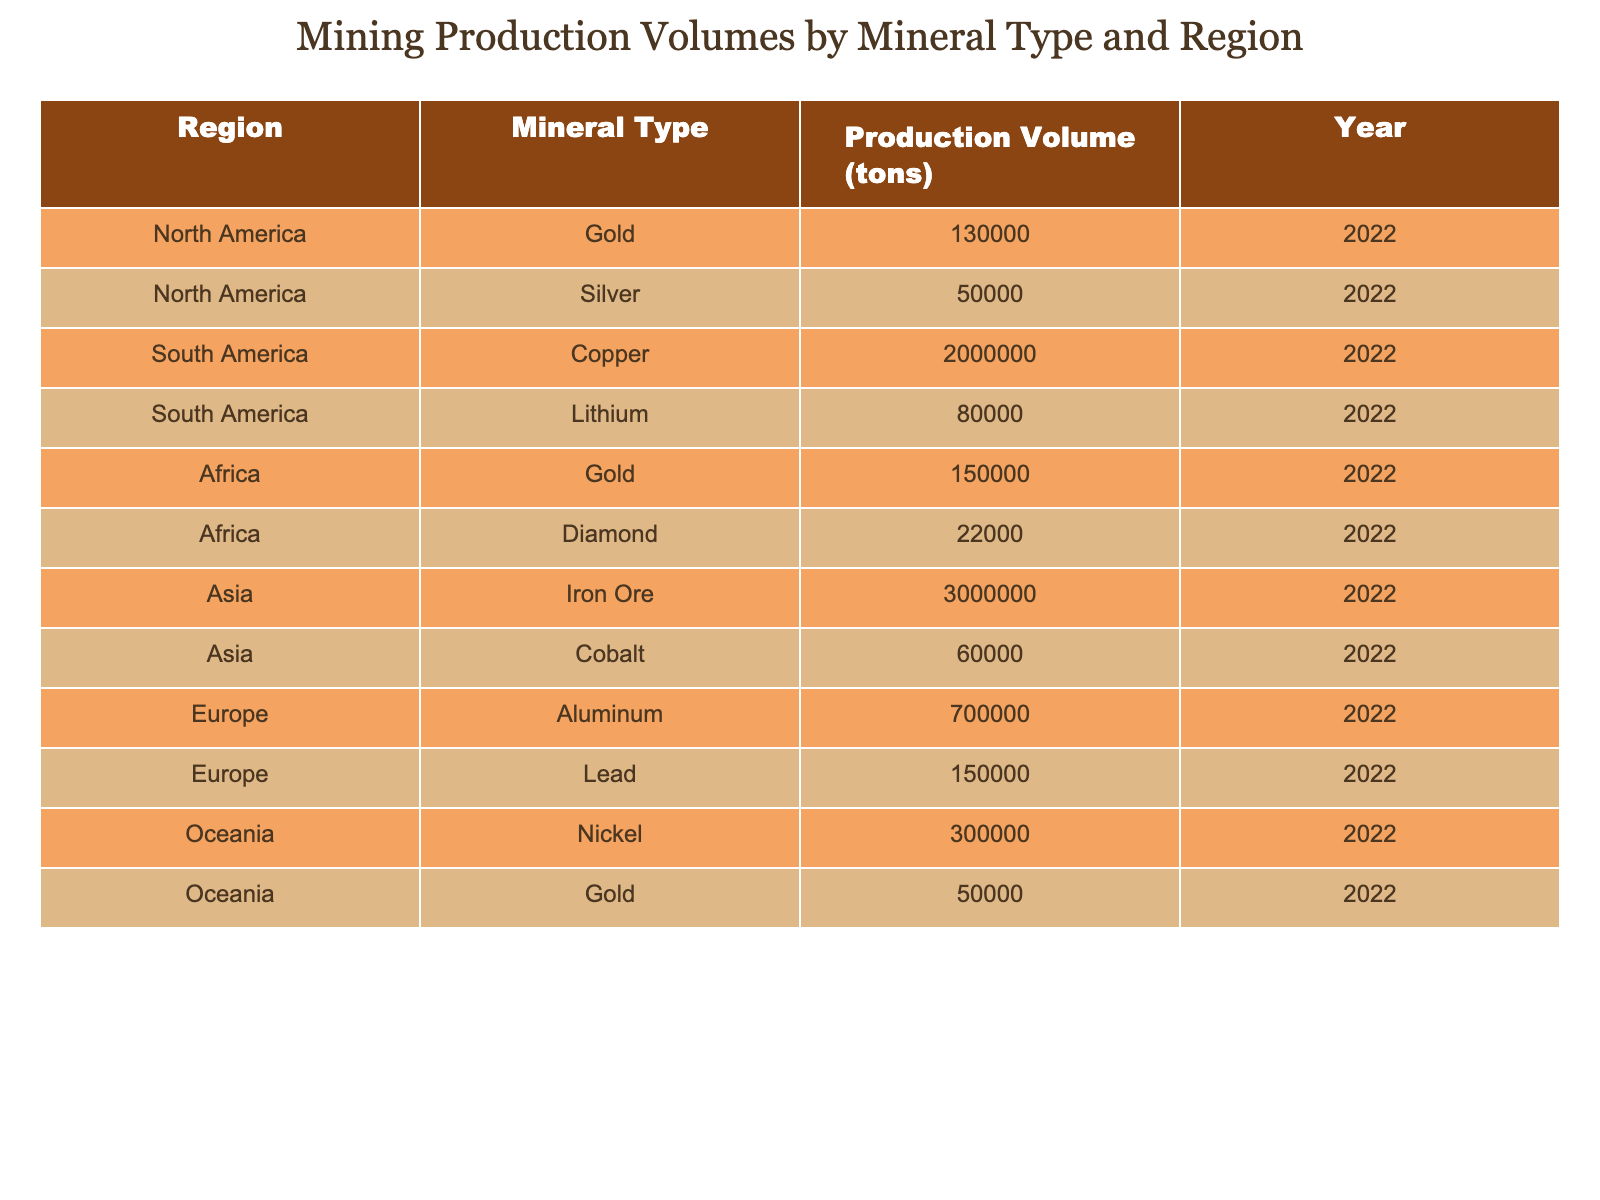What is the production volume of Gold in Africa? The table lists Africa under the Gold mineral type with a production volume of 150,000 tons. Therefore, looking directly at that region and mineral type, the value is straightforward and does not require any additional computations.
Answer: 150,000 tons Which region has the highest production volume for Iron Ore? According to the table, Iron Ore is produced only in Asia with a volume of 3,000,000 tons. This can be confirmed by checking other regions and their mineral types, where Iron Ore is not listed.
Answer: Asia How many tons of Copper are produced in South America? The table specifies that Copper production in South America is 2,000,000 tons. This value is directly stated under the respective region and mineral type, making it easy to retrieve.
Answer: 2,000,000 tons What is the total production volume of Silver and Gold in North America? The production volume of Gold in North America is 130,000 tons and Silver is 50,000 tons. To find the total, we add these two values: 130,000 + 50,000 = 180,000 tons. This requires checking both Gold and Silver's values in the North America section.
Answer: 180,000 tons Is the total production volume of Diamonds higher than that of Lithium? The table indicates that Diamonds have a production volume of 22,000 tons in Africa, and Lithium has 80,000 tons in South America. To determine if Diamonds are higher, we can see that 22,000 tons is less than 80,000 tons. Thus, the answer is derived from directly comparing the two values.
Answer: No What mineral type has the lowest production volume in Oceania? In the table, Oceania has two mineral types listed: Nickel at 300,000 tons and Gold at 50,000 tons. A comparison reveals that Gold at 50,000 tons is lower than Nickel at 300,000 tons, leading to the conclusion that Gold is the mineral with the lowest production volume in this region.
Answer: Gold Calculate the average production volume of minerals in Europe. Europe contains two mineral types: Aluminum with 700,000 tons and Lead with 150,000 tons. To find the average, we sum the volumes, 700,000 + 150,000 = 850,000 tons and divide by the number of mineral types (2): 850,000 / 2 = 425,000 tons. This requires summing the two production volumes first, then calculating the average by dividing by two.
Answer: 425,000 tons Which region produces the most Gold overall? The table shows Gold production volumes: North America has 130,000 tons, Africa has 150,000 tons, and Oceania has 50,000 tons. By comparing these values, Africa's production volume of 150,000 tons is the highest. This necessitates examining the Gold values across all regions to find the maximum.
Answer: Africa 